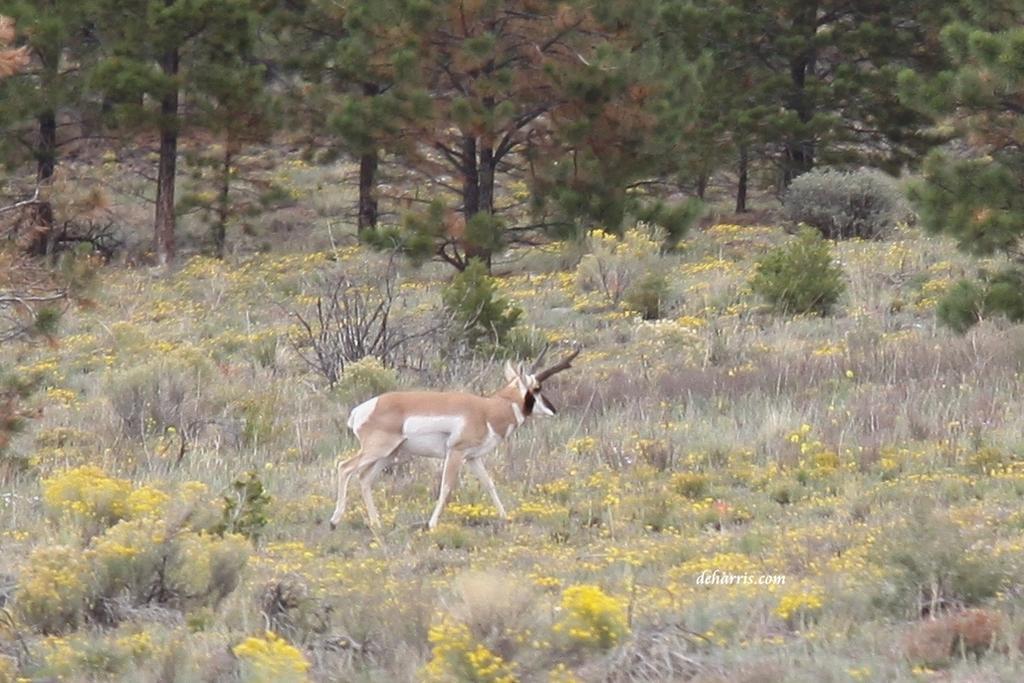Please provide a concise description of this image. In the image there is a deer standing on the grassland with plants and trees in the background. 